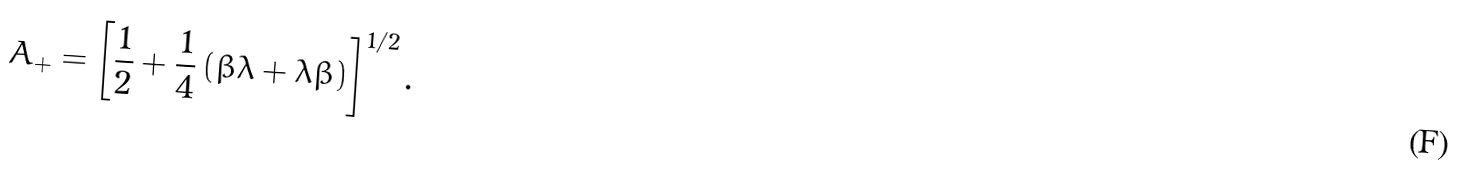Convert formula to latex. <formula><loc_0><loc_0><loc_500><loc_500>A _ { + } = \left [ \frac { 1 } { 2 } + \frac { 1 } { 4 } \left ( \beta \lambda + \lambda \beta \right ) \right ] ^ { 1 / 2 } .</formula> 